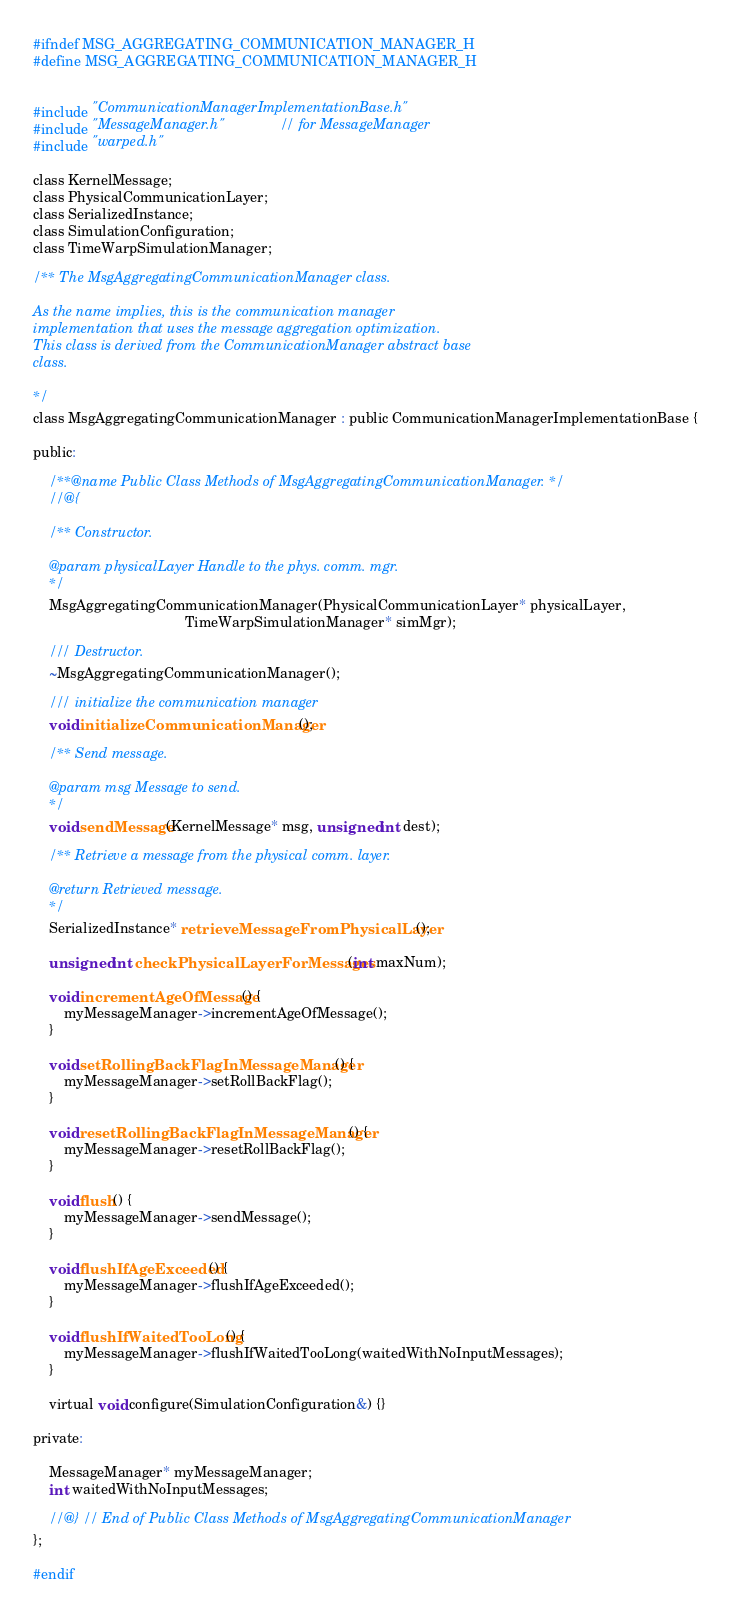Convert code to text. <code><loc_0><loc_0><loc_500><loc_500><_C_>#ifndef MSG_AGGREGATING_COMMUNICATION_MANAGER_H
#define MSG_AGGREGATING_COMMUNICATION_MANAGER_H


#include "CommunicationManagerImplementationBase.h"
#include "MessageManager.h"             // for MessageManager
#include "warped.h"

class KernelMessage;
class PhysicalCommunicationLayer;
class SerializedInstance;
class SimulationConfiguration;
class TimeWarpSimulationManager;

/** The MsgAggregatingCommunicationManager class.

As the name implies, this is the communication manager
implementation that uses the message aggregation optimization.
This class is derived from the CommunicationManager abstract base
class.

*/
class MsgAggregatingCommunicationManager : public CommunicationManagerImplementationBase {

public:

    /**@name Public Class Methods of MsgAggregatingCommunicationManager. */
    //@{

    /** Constructor.

    @param physicalLayer Handle to the phys. comm. mgr.
    */
    MsgAggregatingCommunicationManager(PhysicalCommunicationLayer* physicalLayer,
                                       TimeWarpSimulationManager* simMgr);

    /// Destructor.
    ~MsgAggregatingCommunicationManager();

    /// initialize the communication manager
    void initializeCommunicationManager();

    /** Send message.

    @param msg Message to send.
    */
    void sendMessage(KernelMessage* msg, unsigned int dest);

    /** Retrieve a message from the physical comm. layer.

    @return Retrieved message.
    */
    SerializedInstance* retrieveMessageFromPhysicalLayer();

    unsigned int checkPhysicalLayerForMessages(int maxNum);

    void incrementAgeOfMessage() {
        myMessageManager->incrementAgeOfMessage();
    }

    void setRollingBackFlagInMessageManager() {
        myMessageManager->setRollBackFlag();
    }

    void resetRollingBackFlagInMessageManager() {
        myMessageManager->resetRollBackFlag();
    }

    void flush() {
        myMessageManager->sendMessage();
    }

    void flushIfAgeExceeded() {
        myMessageManager->flushIfAgeExceeded();
    }

    void flushIfWaitedTooLong() {
        myMessageManager->flushIfWaitedTooLong(waitedWithNoInputMessages);
    }

    virtual void configure(SimulationConfiguration&) {}

private:

    MessageManager* myMessageManager;
    int waitedWithNoInputMessages;

    //@} // End of Public Class Methods of MsgAggregatingCommunicationManager
};

#endif
</code> 